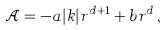<formula> <loc_0><loc_0><loc_500><loc_500>\mathcal { A } = - a | k | r ^ { d + 1 } + b r ^ { d } \, ,</formula> 